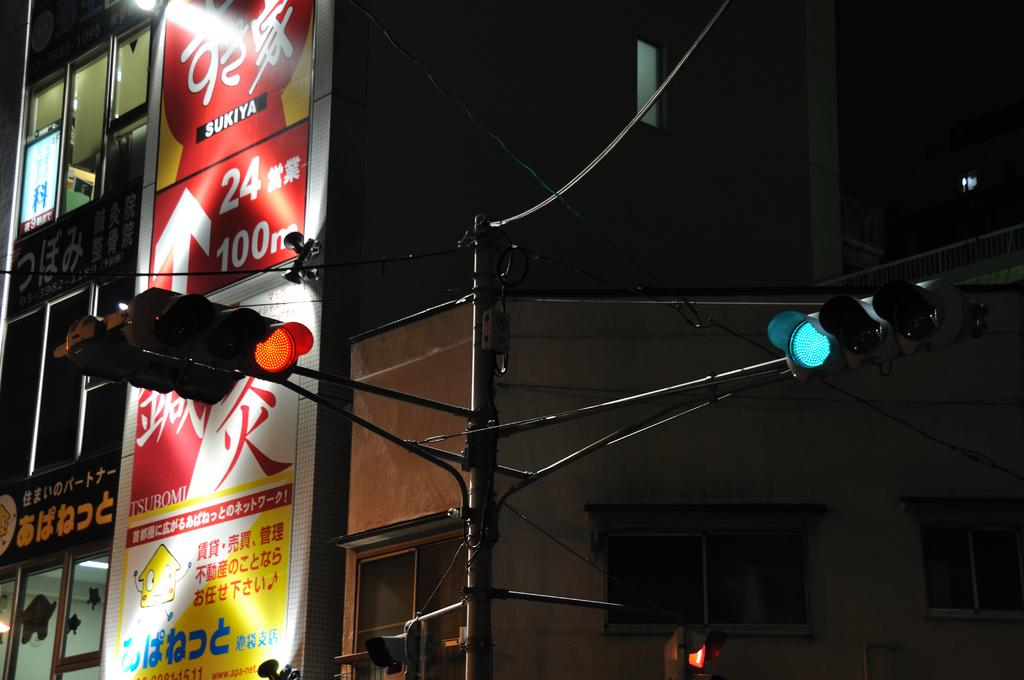<image>
Offer a succinct explanation of the picture presented. A street sign with red and green lights and the number 24 visible. 